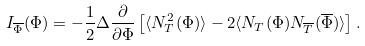<formula> <loc_0><loc_0><loc_500><loc_500>I _ { \overline { \Phi } } ( \Phi ) = - \frac { 1 } { 2 } \Delta \frac { \partial } { \partial \Phi } \left [ \langle N _ { T } ^ { 2 } ( \Phi ) \rangle - 2 \langle N _ { T } ( \Phi ) N _ { \overline { T } } ( \overline { \Phi } ) \rangle \right ] .</formula> 